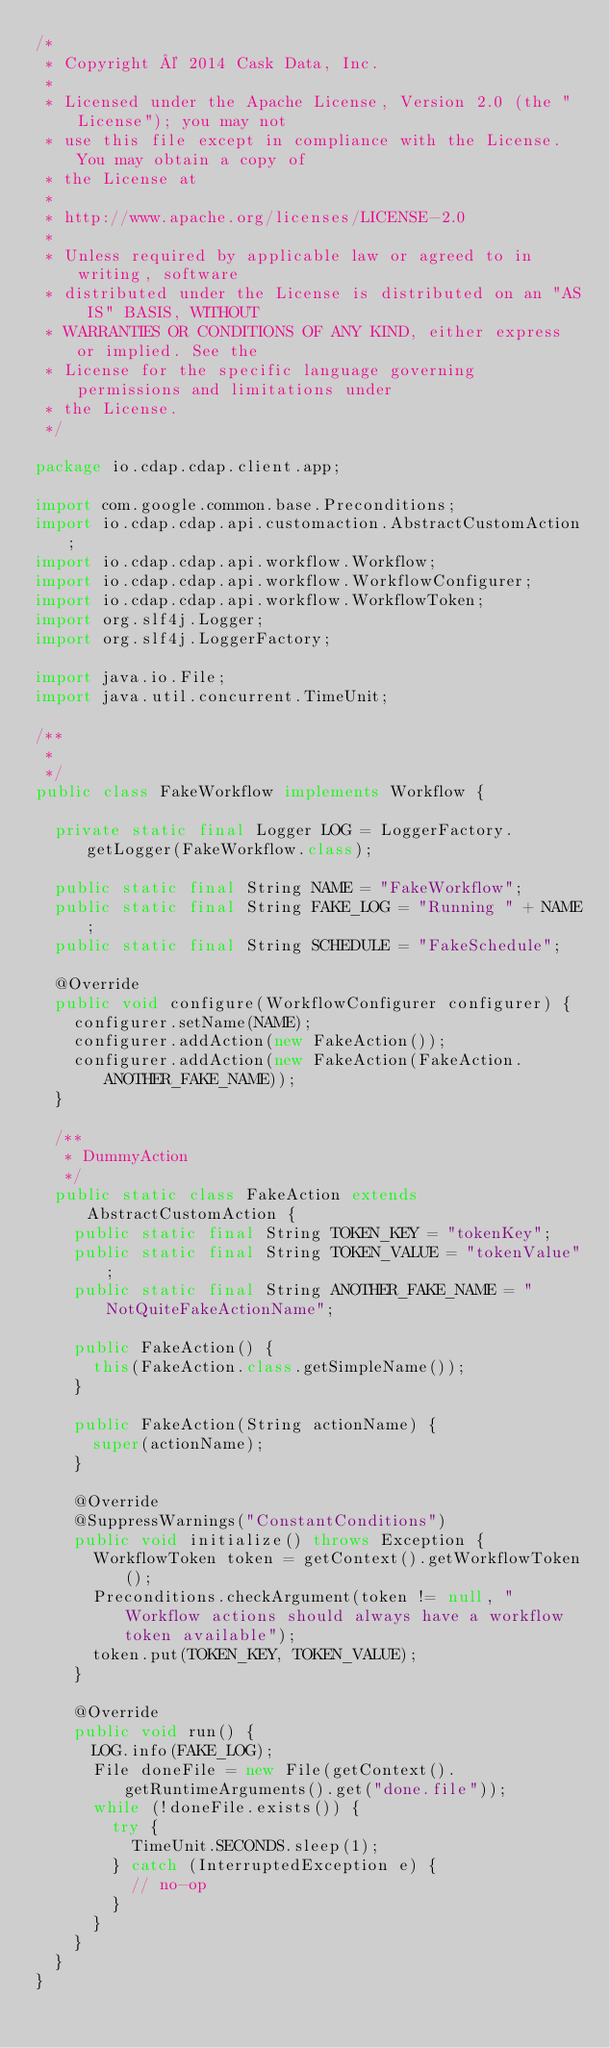<code> <loc_0><loc_0><loc_500><loc_500><_Java_>/*
 * Copyright © 2014 Cask Data, Inc.
 *
 * Licensed under the Apache License, Version 2.0 (the "License"); you may not
 * use this file except in compliance with the License. You may obtain a copy of
 * the License at
 *
 * http://www.apache.org/licenses/LICENSE-2.0
 *
 * Unless required by applicable law or agreed to in writing, software
 * distributed under the License is distributed on an "AS IS" BASIS, WITHOUT
 * WARRANTIES OR CONDITIONS OF ANY KIND, either express or implied. See the
 * License for the specific language governing permissions and limitations under
 * the License.
 */

package io.cdap.cdap.client.app;

import com.google.common.base.Preconditions;
import io.cdap.cdap.api.customaction.AbstractCustomAction;
import io.cdap.cdap.api.workflow.Workflow;
import io.cdap.cdap.api.workflow.WorkflowConfigurer;
import io.cdap.cdap.api.workflow.WorkflowToken;
import org.slf4j.Logger;
import org.slf4j.LoggerFactory;

import java.io.File;
import java.util.concurrent.TimeUnit;

/**
 *
 */
public class FakeWorkflow implements Workflow {

  private static final Logger LOG = LoggerFactory.getLogger(FakeWorkflow.class);

  public static final String NAME = "FakeWorkflow";
  public static final String FAKE_LOG = "Running " + NAME;
  public static final String SCHEDULE = "FakeSchedule";

  @Override
  public void configure(WorkflowConfigurer configurer) {
    configurer.setName(NAME);
    configurer.addAction(new FakeAction());
    configurer.addAction(new FakeAction(FakeAction.ANOTHER_FAKE_NAME));
  }

  /**
   * DummyAction
   */
  public static class FakeAction extends AbstractCustomAction {
    public static final String TOKEN_KEY = "tokenKey";
    public static final String TOKEN_VALUE = "tokenValue";
    public static final String ANOTHER_FAKE_NAME = "NotQuiteFakeActionName";

    public FakeAction() {
      this(FakeAction.class.getSimpleName());
    }

    public FakeAction(String actionName) {
      super(actionName);
    }

    @Override
    @SuppressWarnings("ConstantConditions")
    public void initialize() throws Exception {
      WorkflowToken token = getContext().getWorkflowToken();
      Preconditions.checkArgument(token != null, "Workflow actions should always have a workflow token available");
      token.put(TOKEN_KEY, TOKEN_VALUE);
    }

    @Override
    public void run() {
      LOG.info(FAKE_LOG);
      File doneFile = new File(getContext().getRuntimeArguments().get("done.file"));
      while (!doneFile.exists()) {
        try {
          TimeUnit.SECONDS.sleep(1);
        } catch (InterruptedException e) {
          // no-op
        }
      }
    }
  }
}
</code> 